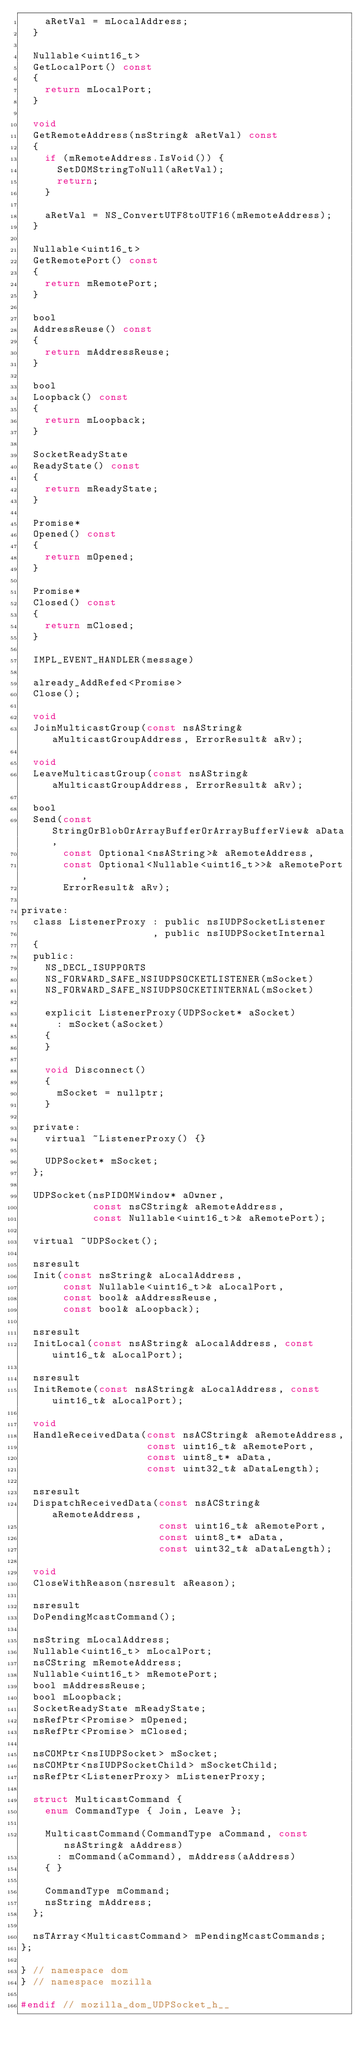<code> <loc_0><loc_0><loc_500><loc_500><_C_>    aRetVal = mLocalAddress;
  }

  Nullable<uint16_t>
  GetLocalPort() const
  {
    return mLocalPort;
  }

  void
  GetRemoteAddress(nsString& aRetVal) const
  {
    if (mRemoteAddress.IsVoid()) {
      SetDOMStringToNull(aRetVal);
      return;
    }

    aRetVal = NS_ConvertUTF8toUTF16(mRemoteAddress);
  }

  Nullable<uint16_t>
  GetRemotePort() const
  {
    return mRemotePort;
  }

  bool
  AddressReuse() const
  {
    return mAddressReuse;
  }

  bool
  Loopback() const
  {
    return mLoopback;
  }

  SocketReadyState
  ReadyState() const
  {
    return mReadyState;
  }

  Promise*
  Opened() const
  {
    return mOpened;
  }

  Promise*
  Closed() const
  {
    return mClosed;
  }

  IMPL_EVENT_HANDLER(message)

  already_AddRefed<Promise>
  Close();

  void
  JoinMulticastGroup(const nsAString& aMulticastGroupAddress, ErrorResult& aRv);

  void
  LeaveMulticastGroup(const nsAString& aMulticastGroupAddress, ErrorResult& aRv);

  bool
  Send(const StringOrBlobOrArrayBufferOrArrayBufferView& aData,
       const Optional<nsAString>& aRemoteAddress,
       const Optional<Nullable<uint16_t>>& aRemotePort,
       ErrorResult& aRv);

private:
  class ListenerProxy : public nsIUDPSocketListener
                      , public nsIUDPSocketInternal
  {
  public:
    NS_DECL_ISUPPORTS
    NS_FORWARD_SAFE_NSIUDPSOCKETLISTENER(mSocket)
    NS_FORWARD_SAFE_NSIUDPSOCKETINTERNAL(mSocket)

    explicit ListenerProxy(UDPSocket* aSocket)
      : mSocket(aSocket)
    {
    }

    void Disconnect()
    {
      mSocket = nullptr;
    }

  private:
    virtual ~ListenerProxy() {}

    UDPSocket* mSocket;
  };

  UDPSocket(nsPIDOMWindow* aOwner,
            const nsCString& aRemoteAddress,
            const Nullable<uint16_t>& aRemotePort);

  virtual ~UDPSocket();

  nsresult
  Init(const nsString& aLocalAddress,
       const Nullable<uint16_t>& aLocalPort,
       const bool& aAddressReuse,
       const bool& aLoopback);

  nsresult
  InitLocal(const nsAString& aLocalAddress, const uint16_t& aLocalPort);

  nsresult
  InitRemote(const nsAString& aLocalAddress, const uint16_t& aLocalPort);

  void
  HandleReceivedData(const nsACString& aRemoteAddress,
                     const uint16_t& aRemotePort,
                     const uint8_t* aData,
                     const uint32_t& aDataLength);

  nsresult
  DispatchReceivedData(const nsACString& aRemoteAddress,
                       const uint16_t& aRemotePort,
                       const uint8_t* aData,
                       const uint32_t& aDataLength);

  void
  CloseWithReason(nsresult aReason);

  nsresult
  DoPendingMcastCommand();

  nsString mLocalAddress;
  Nullable<uint16_t> mLocalPort;
  nsCString mRemoteAddress;
  Nullable<uint16_t> mRemotePort;
  bool mAddressReuse;
  bool mLoopback;
  SocketReadyState mReadyState;
  nsRefPtr<Promise> mOpened;
  nsRefPtr<Promise> mClosed;

  nsCOMPtr<nsIUDPSocket> mSocket;
  nsCOMPtr<nsIUDPSocketChild> mSocketChild;
  nsRefPtr<ListenerProxy> mListenerProxy;

  struct MulticastCommand {
    enum CommandType { Join, Leave };

    MulticastCommand(CommandType aCommand, const nsAString& aAddress)
      : mCommand(aCommand), mAddress(aAddress)
    { }

    CommandType mCommand;
    nsString mAddress;
  };

  nsTArray<MulticastCommand> mPendingMcastCommands;
};

} // namespace dom
} // namespace mozilla

#endif // mozilla_dom_UDPSocket_h__
</code> 